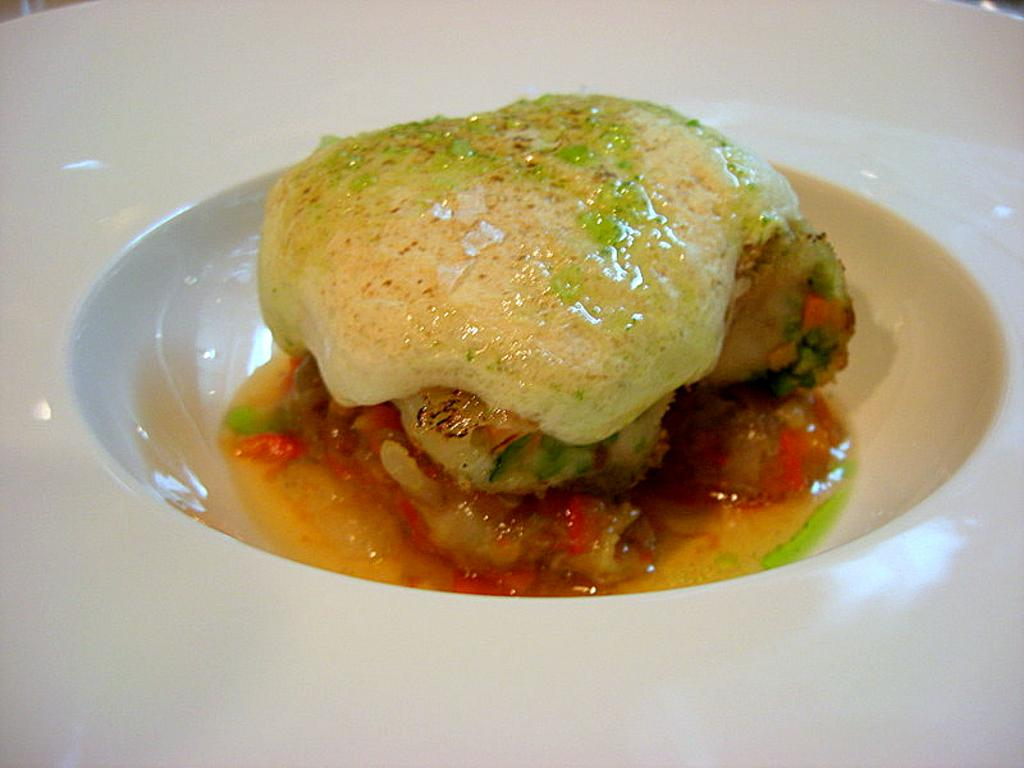What is the color of the bowl-like object in the image? The bowl-like object in the image is white. What is inside the bowl-like object? There is food in the bowl-like object. Is the bowl-like object being used for a bath in the image? No, the bowl-like object is not being used for a bath in the image; it contains food. 